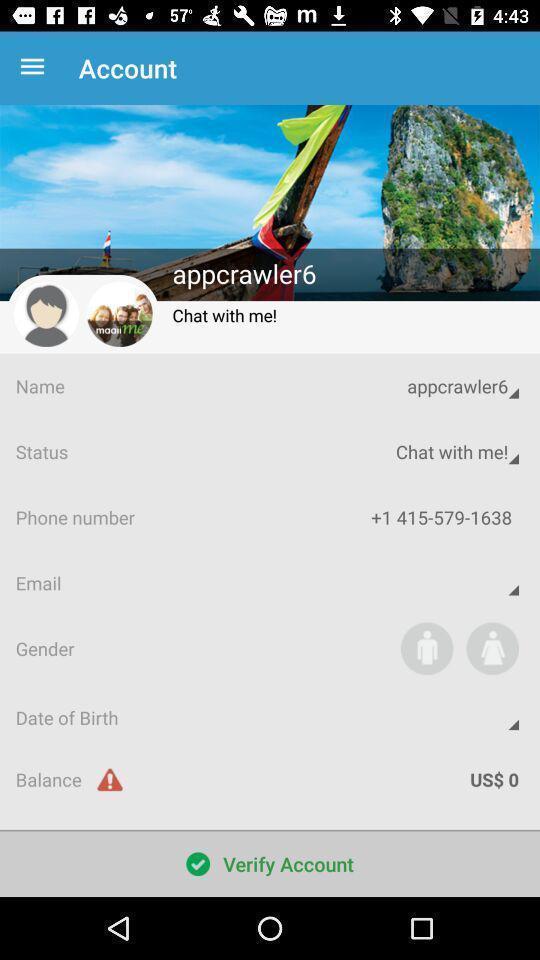What details can you identify in this image? Page displays details of an account. 